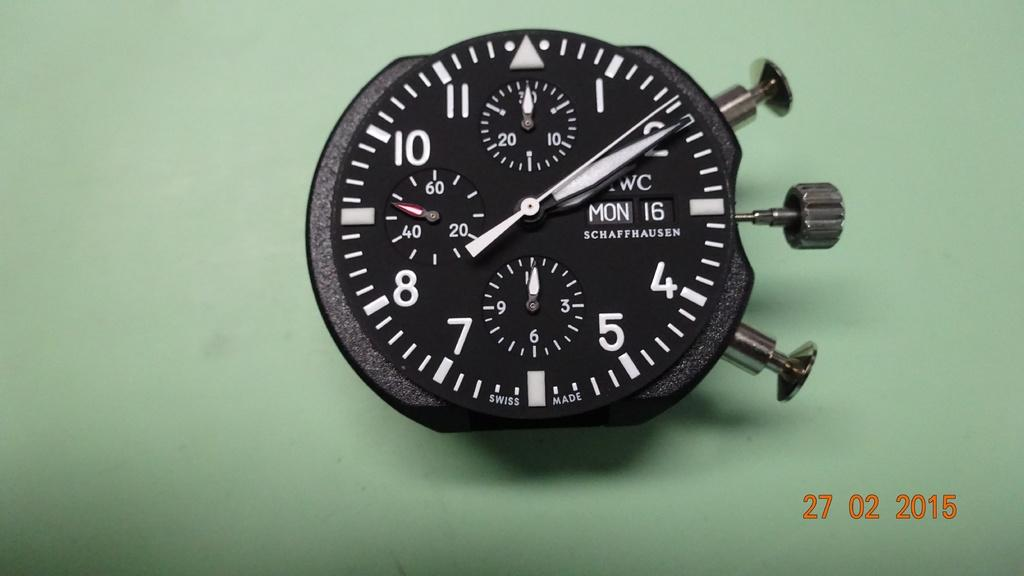Provide a one-sentence caption for the provided image. A Schaffhausen stop watch on a green background. 